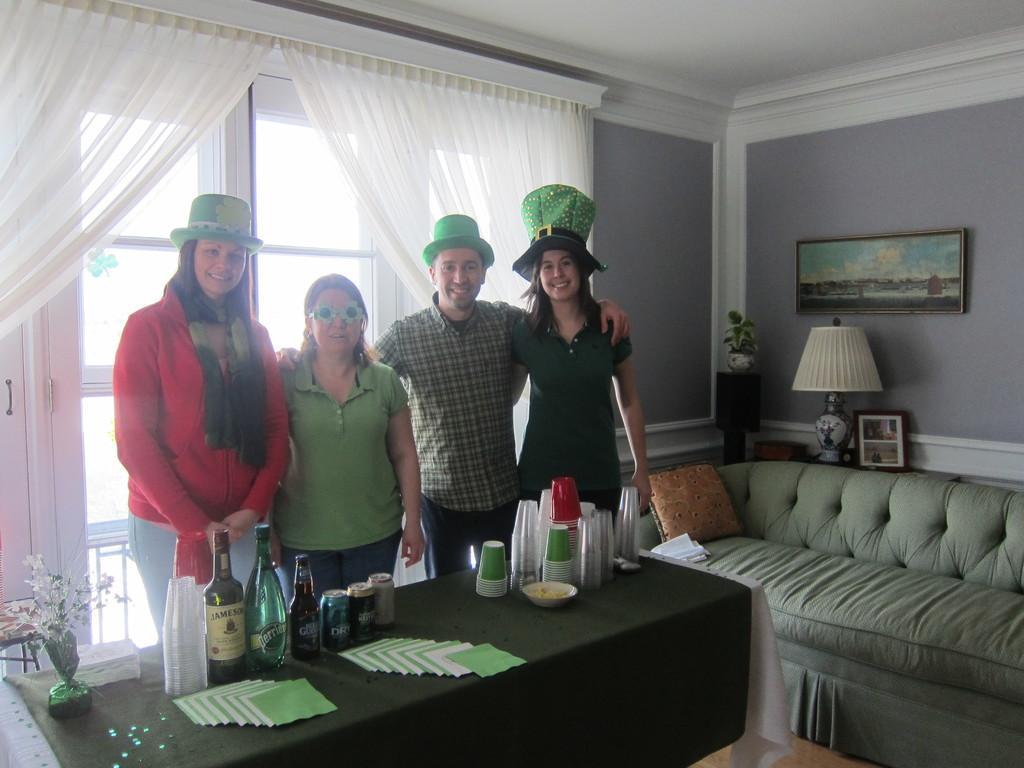Could you give a brief overview of what you see in this image? In the picture we can find four people standing near the table, three women and one man, on the table we can find the glasses, bottles and cards beside to them we can see a sofa and pillow on it and we can also see the lamp, photo, wall. And in the background we can find curtain, window and curtain is in white color and the people are wearing hats. 